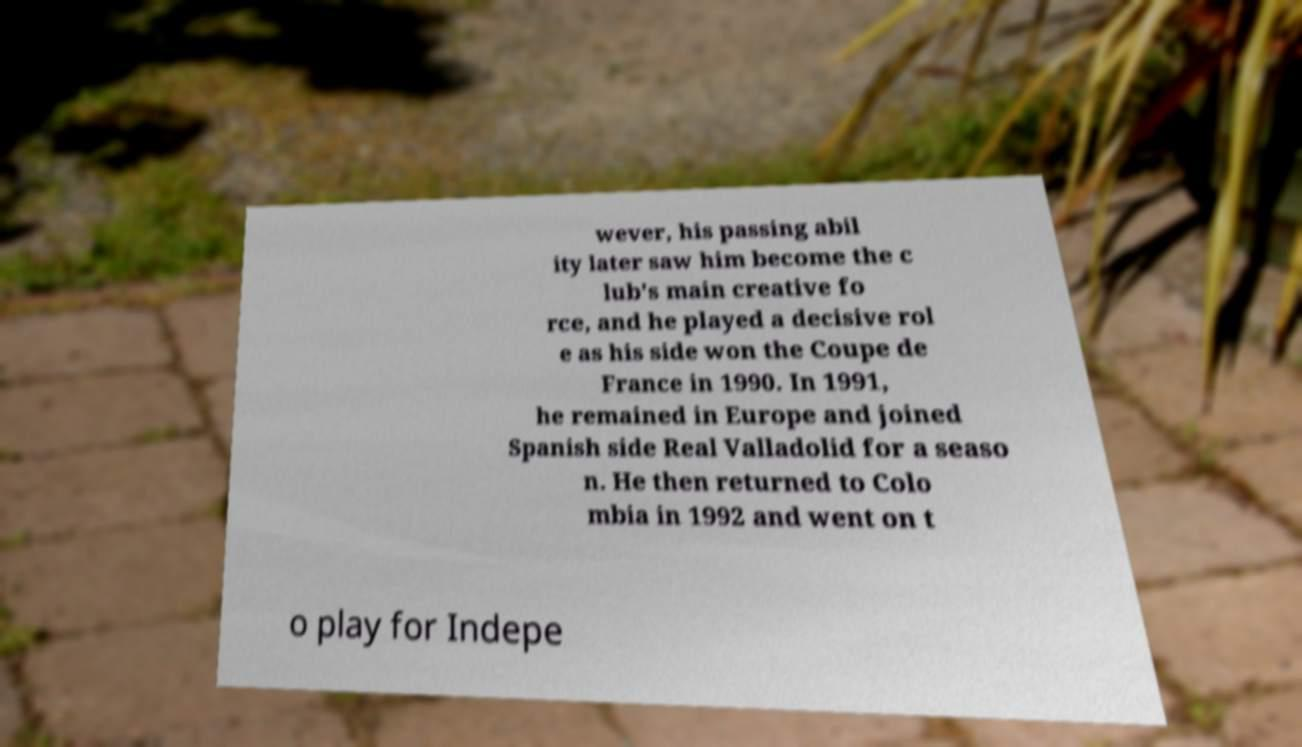What messages or text are displayed in this image? I need them in a readable, typed format. wever, his passing abil ity later saw him become the c lub's main creative fo rce, and he played a decisive rol e as his side won the Coupe de France in 1990. In 1991, he remained in Europe and joined Spanish side Real Valladolid for a seaso n. He then returned to Colo mbia in 1992 and went on t o play for Indepe 